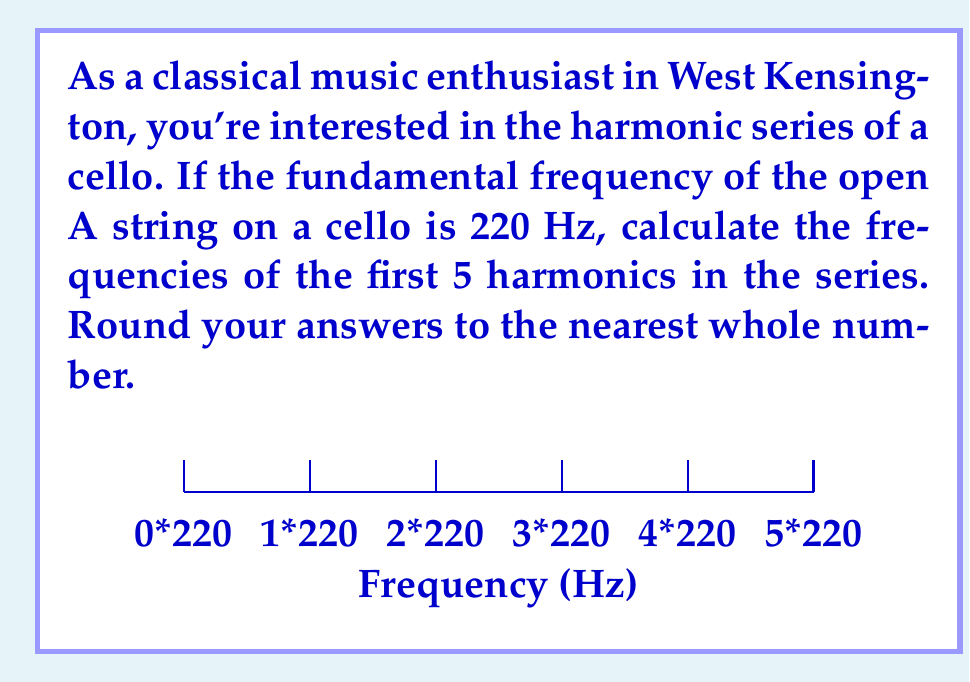What is the answer to this math problem? To compute the harmonic series of a musical instrument, we need to understand that each harmonic is a multiple of the fundamental frequency. Here's how we calculate the first 5 harmonics:

1) The fundamental frequency (1st harmonic) is given: 220 Hz

2) For the subsequent harmonics, we multiply the fundamental frequency by the harmonic number:

   2nd harmonic: $220 \times 2 = 440$ Hz
   3rd harmonic: $220 \times 3 = 660$ Hz
   4th harmonic: $220 \times 4 = 880$ Hz
   5th harmonic: $220 \times 5 = 1100$ Hz

3) The general formula for the nth harmonic is:

   $$f_n = n \times f_1$$

   Where $f_n$ is the frequency of the nth harmonic and $f_1$ is the fundamental frequency.

4) Rounding to the nearest whole number:
   220 Hz, 440 Hz, 660 Hz, 880 Hz, 1100 Hz

These harmonics contribute to the rich, warm tone of the cello that classical music lovers in West Kensington and around the world appreciate.
Answer: 220, 440, 660, 880, 1100 